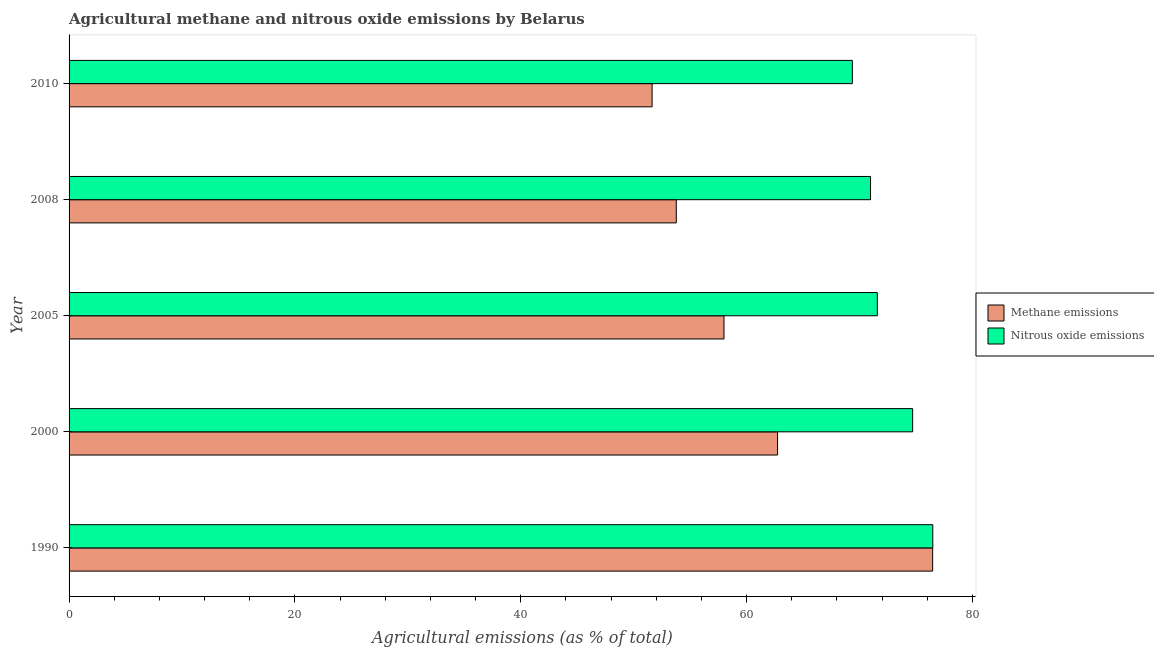How many different coloured bars are there?
Make the answer very short. 2. Are the number of bars per tick equal to the number of legend labels?
Keep it short and to the point. Yes. How many bars are there on the 2nd tick from the top?
Keep it short and to the point. 2. What is the amount of nitrous oxide emissions in 2000?
Offer a very short reply. 74.72. Across all years, what is the maximum amount of nitrous oxide emissions?
Offer a very short reply. 76.5. Across all years, what is the minimum amount of nitrous oxide emissions?
Keep it short and to the point. 69.37. What is the total amount of nitrous oxide emissions in the graph?
Provide a short and direct response. 363.16. What is the difference between the amount of nitrous oxide emissions in 1990 and that in 2005?
Provide a short and direct response. 4.91. What is the difference between the amount of methane emissions in 2008 and the amount of nitrous oxide emissions in 2010?
Ensure brevity in your answer.  -15.6. What is the average amount of methane emissions per year?
Provide a short and direct response. 60.53. In the year 2000, what is the difference between the amount of nitrous oxide emissions and amount of methane emissions?
Give a very brief answer. 11.97. Is the amount of methane emissions in 2005 less than that in 2008?
Your answer should be compact. No. Is the difference between the amount of methane emissions in 2000 and 2010 greater than the difference between the amount of nitrous oxide emissions in 2000 and 2010?
Offer a very short reply. Yes. What is the difference between the highest and the second highest amount of methane emissions?
Offer a very short reply. 13.74. What is the difference between the highest and the lowest amount of nitrous oxide emissions?
Your answer should be compact. 7.12. Is the sum of the amount of nitrous oxide emissions in 1990 and 2005 greater than the maximum amount of methane emissions across all years?
Provide a short and direct response. Yes. What does the 2nd bar from the top in 2008 represents?
Keep it short and to the point. Methane emissions. What does the 1st bar from the bottom in 2000 represents?
Provide a short and direct response. Methane emissions. What is the difference between two consecutive major ticks on the X-axis?
Give a very brief answer. 20. Where does the legend appear in the graph?
Give a very brief answer. Center right. How many legend labels are there?
Keep it short and to the point. 2. What is the title of the graph?
Your answer should be compact. Agricultural methane and nitrous oxide emissions by Belarus. What is the label or title of the X-axis?
Keep it short and to the point. Agricultural emissions (as % of total). What is the label or title of the Y-axis?
Give a very brief answer. Year. What is the Agricultural emissions (as % of total) of Methane emissions in 1990?
Provide a short and direct response. 76.49. What is the Agricultural emissions (as % of total) of Nitrous oxide emissions in 1990?
Offer a terse response. 76.5. What is the Agricultural emissions (as % of total) in Methane emissions in 2000?
Your response must be concise. 62.75. What is the Agricultural emissions (as % of total) in Nitrous oxide emissions in 2000?
Make the answer very short. 74.72. What is the Agricultural emissions (as % of total) in Methane emissions in 2005?
Provide a succinct answer. 58.01. What is the Agricultural emissions (as % of total) in Nitrous oxide emissions in 2005?
Give a very brief answer. 71.59. What is the Agricultural emissions (as % of total) in Methane emissions in 2008?
Offer a very short reply. 53.78. What is the Agricultural emissions (as % of total) of Nitrous oxide emissions in 2008?
Your answer should be very brief. 70.98. What is the Agricultural emissions (as % of total) of Methane emissions in 2010?
Your answer should be compact. 51.64. What is the Agricultural emissions (as % of total) in Nitrous oxide emissions in 2010?
Offer a terse response. 69.37. Across all years, what is the maximum Agricultural emissions (as % of total) in Methane emissions?
Your answer should be very brief. 76.49. Across all years, what is the maximum Agricultural emissions (as % of total) of Nitrous oxide emissions?
Your response must be concise. 76.5. Across all years, what is the minimum Agricultural emissions (as % of total) in Methane emissions?
Make the answer very short. 51.64. Across all years, what is the minimum Agricultural emissions (as % of total) in Nitrous oxide emissions?
Provide a short and direct response. 69.37. What is the total Agricultural emissions (as % of total) of Methane emissions in the graph?
Keep it short and to the point. 302.66. What is the total Agricultural emissions (as % of total) of Nitrous oxide emissions in the graph?
Your response must be concise. 363.16. What is the difference between the Agricultural emissions (as % of total) in Methane emissions in 1990 and that in 2000?
Make the answer very short. 13.74. What is the difference between the Agricultural emissions (as % of total) in Nitrous oxide emissions in 1990 and that in 2000?
Your answer should be compact. 1.78. What is the difference between the Agricultural emissions (as % of total) in Methane emissions in 1990 and that in 2005?
Provide a succinct answer. 18.48. What is the difference between the Agricultural emissions (as % of total) in Nitrous oxide emissions in 1990 and that in 2005?
Provide a succinct answer. 4.91. What is the difference between the Agricultural emissions (as % of total) of Methane emissions in 1990 and that in 2008?
Your answer should be very brief. 22.71. What is the difference between the Agricultural emissions (as % of total) of Nitrous oxide emissions in 1990 and that in 2008?
Provide a short and direct response. 5.51. What is the difference between the Agricultural emissions (as % of total) in Methane emissions in 1990 and that in 2010?
Keep it short and to the point. 24.85. What is the difference between the Agricultural emissions (as % of total) of Nitrous oxide emissions in 1990 and that in 2010?
Provide a short and direct response. 7.12. What is the difference between the Agricultural emissions (as % of total) of Methane emissions in 2000 and that in 2005?
Keep it short and to the point. 4.74. What is the difference between the Agricultural emissions (as % of total) of Nitrous oxide emissions in 2000 and that in 2005?
Keep it short and to the point. 3.13. What is the difference between the Agricultural emissions (as % of total) in Methane emissions in 2000 and that in 2008?
Ensure brevity in your answer.  8.97. What is the difference between the Agricultural emissions (as % of total) of Nitrous oxide emissions in 2000 and that in 2008?
Offer a terse response. 3.73. What is the difference between the Agricultural emissions (as % of total) in Methane emissions in 2000 and that in 2010?
Provide a succinct answer. 11.11. What is the difference between the Agricultural emissions (as % of total) in Nitrous oxide emissions in 2000 and that in 2010?
Offer a terse response. 5.34. What is the difference between the Agricultural emissions (as % of total) in Methane emissions in 2005 and that in 2008?
Your response must be concise. 4.23. What is the difference between the Agricultural emissions (as % of total) in Nitrous oxide emissions in 2005 and that in 2008?
Provide a short and direct response. 0.6. What is the difference between the Agricultural emissions (as % of total) of Methane emissions in 2005 and that in 2010?
Your answer should be compact. 6.37. What is the difference between the Agricultural emissions (as % of total) of Nitrous oxide emissions in 2005 and that in 2010?
Ensure brevity in your answer.  2.21. What is the difference between the Agricultural emissions (as % of total) in Methane emissions in 2008 and that in 2010?
Offer a very short reply. 2.14. What is the difference between the Agricultural emissions (as % of total) in Nitrous oxide emissions in 2008 and that in 2010?
Your answer should be compact. 1.61. What is the difference between the Agricultural emissions (as % of total) of Methane emissions in 1990 and the Agricultural emissions (as % of total) of Nitrous oxide emissions in 2000?
Your response must be concise. 1.77. What is the difference between the Agricultural emissions (as % of total) in Methane emissions in 1990 and the Agricultural emissions (as % of total) in Nitrous oxide emissions in 2005?
Offer a terse response. 4.9. What is the difference between the Agricultural emissions (as % of total) of Methane emissions in 1990 and the Agricultural emissions (as % of total) of Nitrous oxide emissions in 2008?
Provide a succinct answer. 5.5. What is the difference between the Agricultural emissions (as % of total) in Methane emissions in 1990 and the Agricultural emissions (as % of total) in Nitrous oxide emissions in 2010?
Provide a short and direct response. 7.11. What is the difference between the Agricultural emissions (as % of total) of Methane emissions in 2000 and the Agricultural emissions (as % of total) of Nitrous oxide emissions in 2005?
Provide a succinct answer. -8.84. What is the difference between the Agricultural emissions (as % of total) in Methane emissions in 2000 and the Agricultural emissions (as % of total) in Nitrous oxide emissions in 2008?
Your answer should be very brief. -8.23. What is the difference between the Agricultural emissions (as % of total) in Methane emissions in 2000 and the Agricultural emissions (as % of total) in Nitrous oxide emissions in 2010?
Your answer should be very brief. -6.62. What is the difference between the Agricultural emissions (as % of total) in Methane emissions in 2005 and the Agricultural emissions (as % of total) in Nitrous oxide emissions in 2008?
Give a very brief answer. -12.98. What is the difference between the Agricultural emissions (as % of total) of Methane emissions in 2005 and the Agricultural emissions (as % of total) of Nitrous oxide emissions in 2010?
Ensure brevity in your answer.  -11.37. What is the difference between the Agricultural emissions (as % of total) in Methane emissions in 2008 and the Agricultural emissions (as % of total) in Nitrous oxide emissions in 2010?
Your answer should be very brief. -15.6. What is the average Agricultural emissions (as % of total) of Methane emissions per year?
Make the answer very short. 60.53. What is the average Agricultural emissions (as % of total) in Nitrous oxide emissions per year?
Give a very brief answer. 72.63. In the year 1990, what is the difference between the Agricultural emissions (as % of total) of Methane emissions and Agricultural emissions (as % of total) of Nitrous oxide emissions?
Ensure brevity in your answer.  -0.01. In the year 2000, what is the difference between the Agricultural emissions (as % of total) in Methane emissions and Agricultural emissions (as % of total) in Nitrous oxide emissions?
Provide a short and direct response. -11.97. In the year 2005, what is the difference between the Agricultural emissions (as % of total) in Methane emissions and Agricultural emissions (as % of total) in Nitrous oxide emissions?
Make the answer very short. -13.58. In the year 2008, what is the difference between the Agricultural emissions (as % of total) of Methane emissions and Agricultural emissions (as % of total) of Nitrous oxide emissions?
Give a very brief answer. -17.2. In the year 2010, what is the difference between the Agricultural emissions (as % of total) of Methane emissions and Agricultural emissions (as % of total) of Nitrous oxide emissions?
Make the answer very short. -17.74. What is the ratio of the Agricultural emissions (as % of total) in Methane emissions in 1990 to that in 2000?
Provide a short and direct response. 1.22. What is the ratio of the Agricultural emissions (as % of total) of Nitrous oxide emissions in 1990 to that in 2000?
Provide a succinct answer. 1.02. What is the ratio of the Agricultural emissions (as % of total) in Methane emissions in 1990 to that in 2005?
Keep it short and to the point. 1.32. What is the ratio of the Agricultural emissions (as % of total) in Nitrous oxide emissions in 1990 to that in 2005?
Your answer should be very brief. 1.07. What is the ratio of the Agricultural emissions (as % of total) of Methane emissions in 1990 to that in 2008?
Offer a terse response. 1.42. What is the ratio of the Agricultural emissions (as % of total) of Nitrous oxide emissions in 1990 to that in 2008?
Offer a terse response. 1.08. What is the ratio of the Agricultural emissions (as % of total) of Methane emissions in 1990 to that in 2010?
Offer a terse response. 1.48. What is the ratio of the Agricultural emissions (as % of total) in Nitrous oxide emissions in 1990 to that in 2010?
Your response must be concise. 1.1. What is the ratio of the Agricultural emissions (as % of total) of Methane emissions in 2000 to that in 2005?
Your answer should be very brief. 1.08. What is the ratio of the Agricultural emissions (as % of total) in Nitrous oxide emissions in 2000 to that in 2005?
Your answer should be very brief. 1.04. What is the ratio of the Agricultural emissions (as % of total) of Methane emissions in 2000 to that in 2008?
Provide a succinct answer. 1.17. What is the ratio of the Agricultural emissions (as % of total) of Nitrous oxide emissions in 2000 to that in 2008?
Your answer should be very brief. 1.05. What is the ratio of the Agricultural emissions (as % of total) of Methane emissions in 2000 to that in 2010?
Provide a short and direct response. 1.22. What is the ratio of the Agricultural emissions (as % of total) of Nitrous oxide emissions in 2000 to that in 2010?
Offer a very short reply. 1.08. What is the ratio of the Agricultural emissions (as % of total) of Methane emissions in 2005 to that in 2008?
Make the answer very short. 1.08. What is the ratio of the Agricultural emissions (as % of total) in Nitrous oxide emissions in 2005 to that in 2008?
Provide a succinct answer. 1.01. What is the ratio of the Agricultural emissions (as % of total) in Methane emissions in 2005 to that in 2010?
Your response must be concise. 1.12. What is the ratio of the Agricultural emissions (as % of total) in Nitrous oxide emissions in 2005 to that in 2010?
Give a very brief answer. 1.03. What is the ratio of the Agricultural emissions (as % of total) in Methane emissions in 2008 to that in 2010?
Your answer should be compact. 1.04. What is the ratio of the Agricultural emissions (as % of total) of Nitrous oxide emissions in 2008 to that in 2010?
Your answer should be very brief. 1.02. What is the difference between the highest and the second highest Agricultural emissions (as % of total) of Methane emissions?
Offer a terse response. 13.74. What is the difference between the highest and the second highest Agricultural emissions (as % of total) in Nitrous oxide emissions?
Your answer should be compact. 1.78. What is the difference between the highest and the lowest Agricultural emissions (as % of total) of Methane emissions?
Offer a very short reply. 24.85. What is the difference between the highest and the lowest Agricultural emissions (as % of total) in Nitrous oxide emissions?
Offer a terse response. 7.12. 